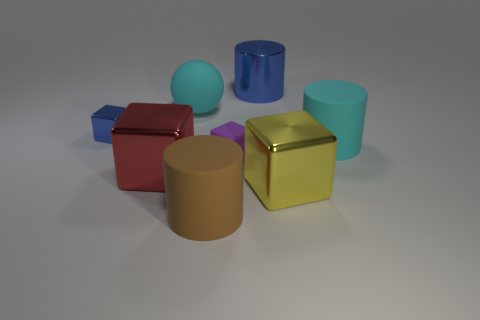What is the size of the matte object that is the same shape as the yellow metal thing?
Offer a terse response. Small. How many other things are made of the same material as the purple cube?
Provide a short and direct response. 3. What is the material of the brown cylinder?
Give a very brief answer. Rubber. Is the color of the matte cylinder behind the tiny rubber object the same as the large rubber thing that is behind the tiny blue metallic block?
Your response must be concise. Yes. Is the number of big balls that are behind the large yellow thing greater than the number of gray shiny spheres?
Your response must be concise. Yes. What number of other objects are the same color as the tiny rubber block?
Your response must be concise. 0. Is the size of the cylinder that is behind the cyan rubber cylinder the same as the big cyan cylinder?
Ensure brevity in your answer.  Yes. Are there any blue matte cylinders that have the same size as the yellow shiny object?
Provide a succinct answer. No. There is a big rubber cylinder in front of the yellow block; what is its color?
Your answer should be compact. Brown. The large object that is to the right of the tiny matte object and behind the blue metal cube has what shape?
Make the answer very short. Cylinder. 